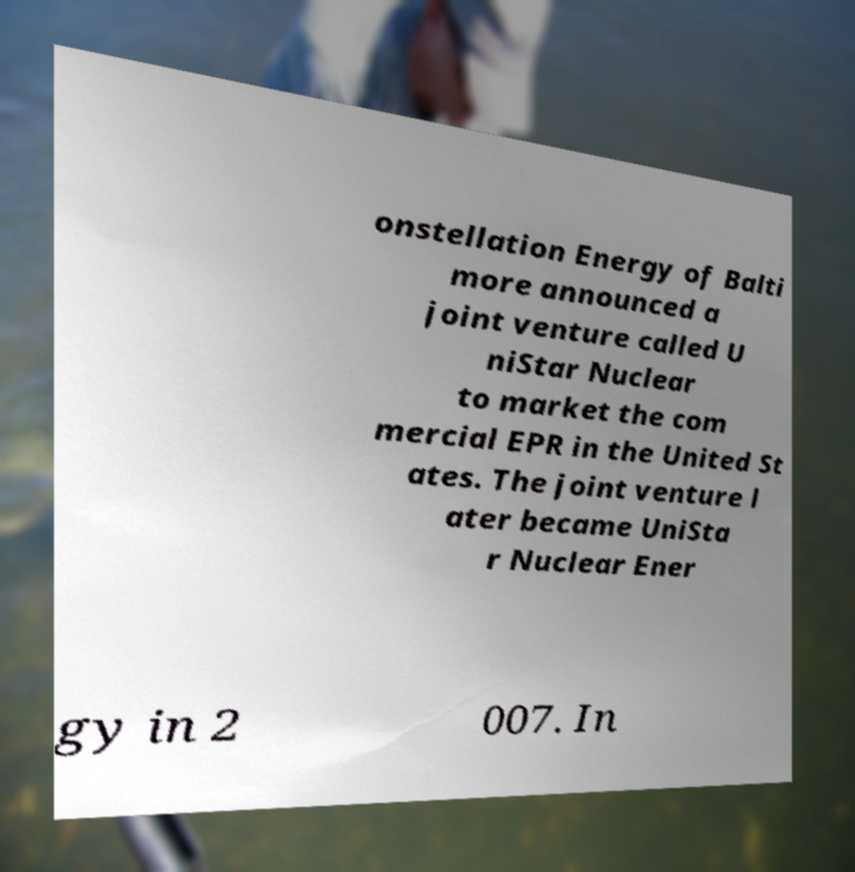For documentation purposes, I need the text within this image transcribed. Could you provide that? onstellation Energy of Balti more announced a joint venture called U niStar Nuclear to market the com mercial EPR in the United St ates. The joint venture l ater became UniSta r Nuclear Ener gy in 2 007. In 